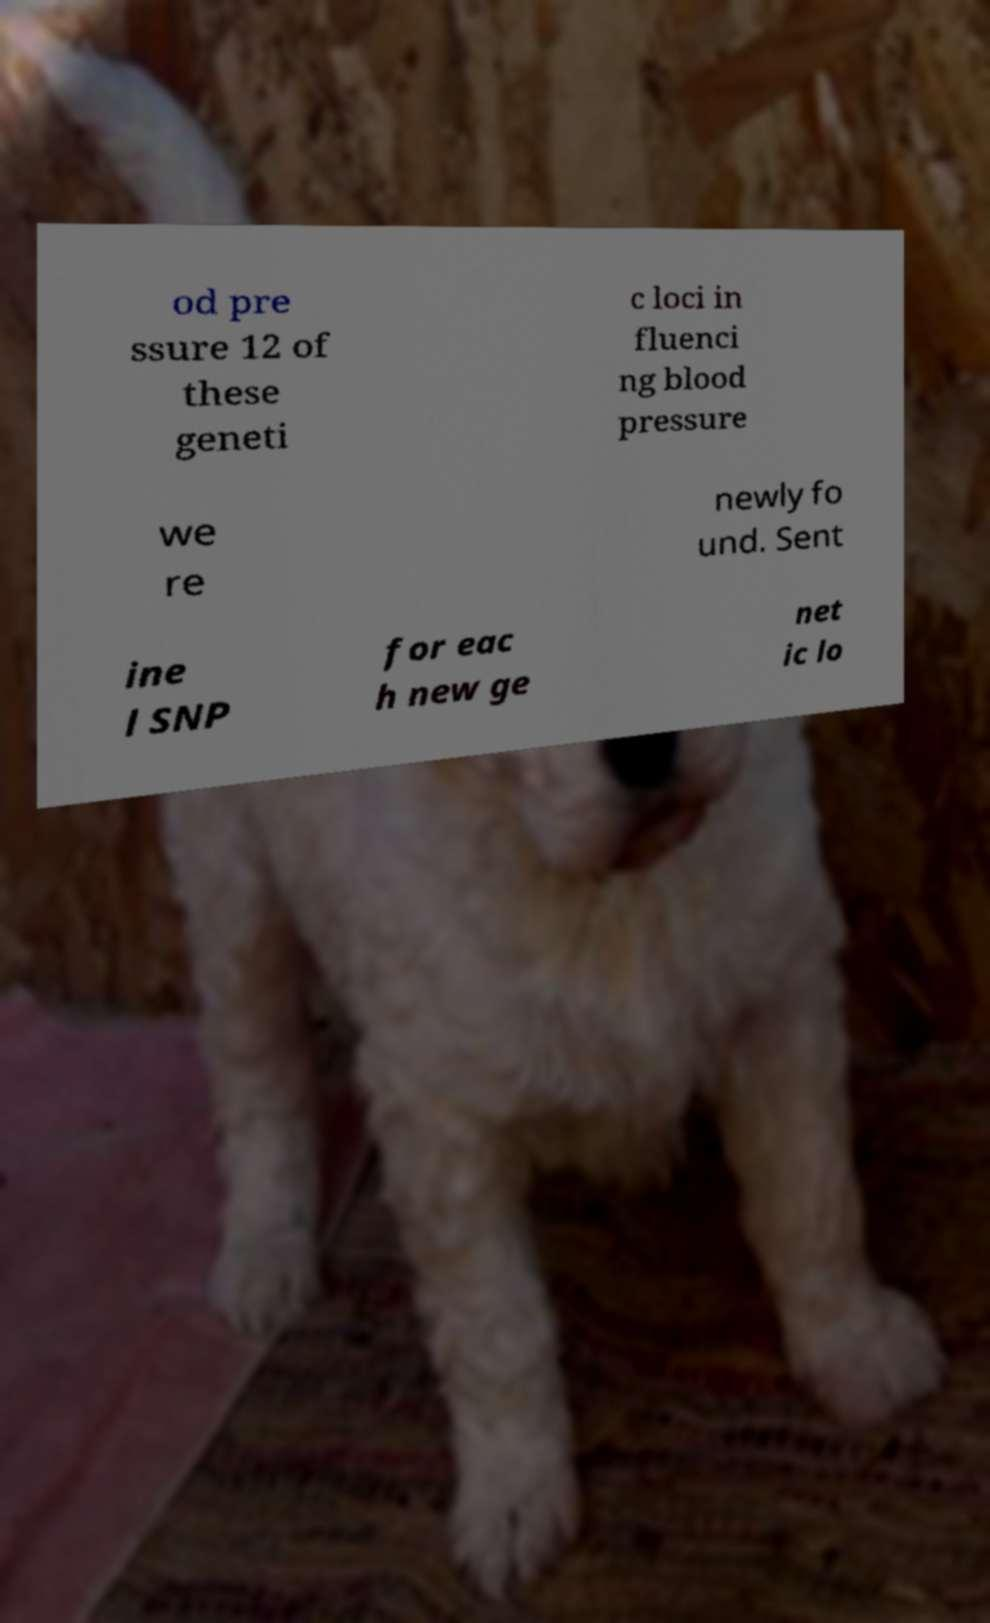For documentation purposes, I need the text within this image transcribed. Could you provide that? od pre ssure 12 of these geneti c loci in fluenci ng blood pressure we re newly fo und. Sent ine l SNP for eac h new ge net ic lo 